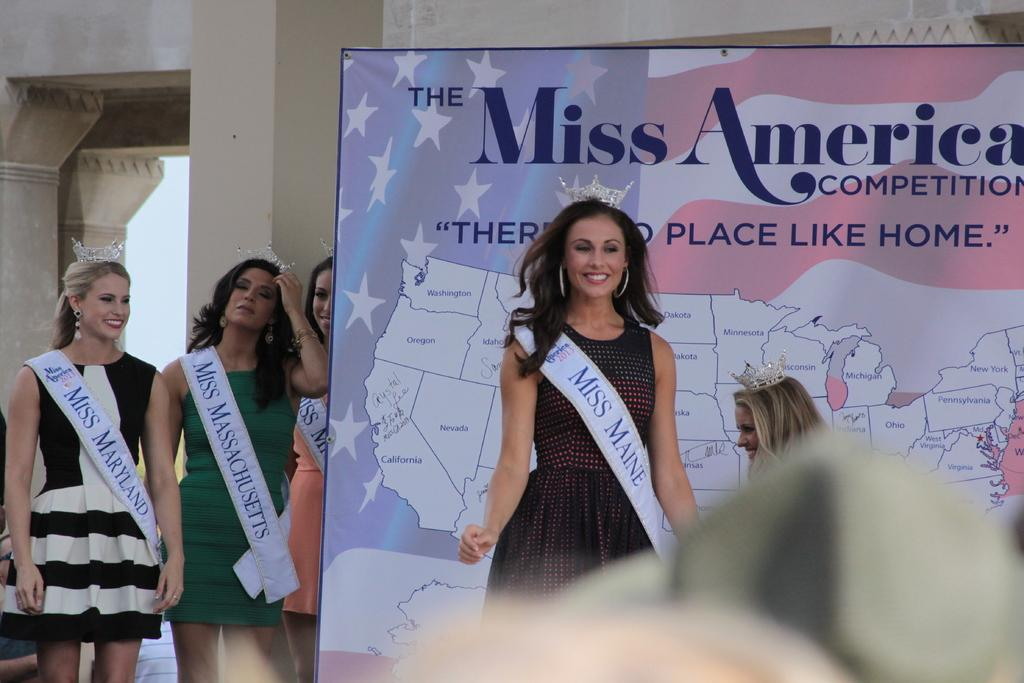<image>
Relay a brief, clear account of the picture shown. Five Miss America contestants are on the stage. 